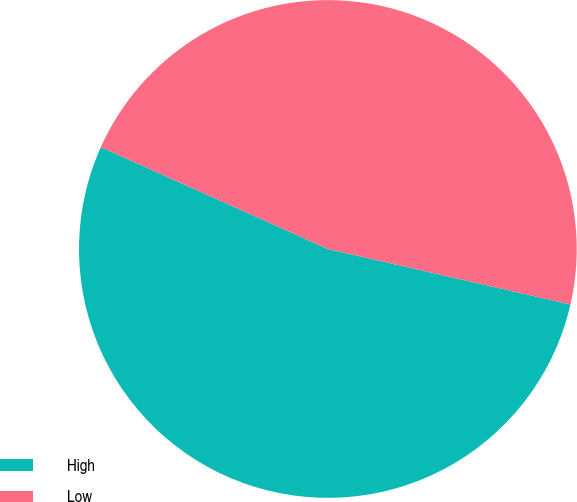Convert chart to OTSL. <chart><loc_0><loc_0><loc_500><loc_500><pie_chart><fcel>High<fcel>Low<nl><fcel>53.13%<fcel>46.87%<nl></chart> 